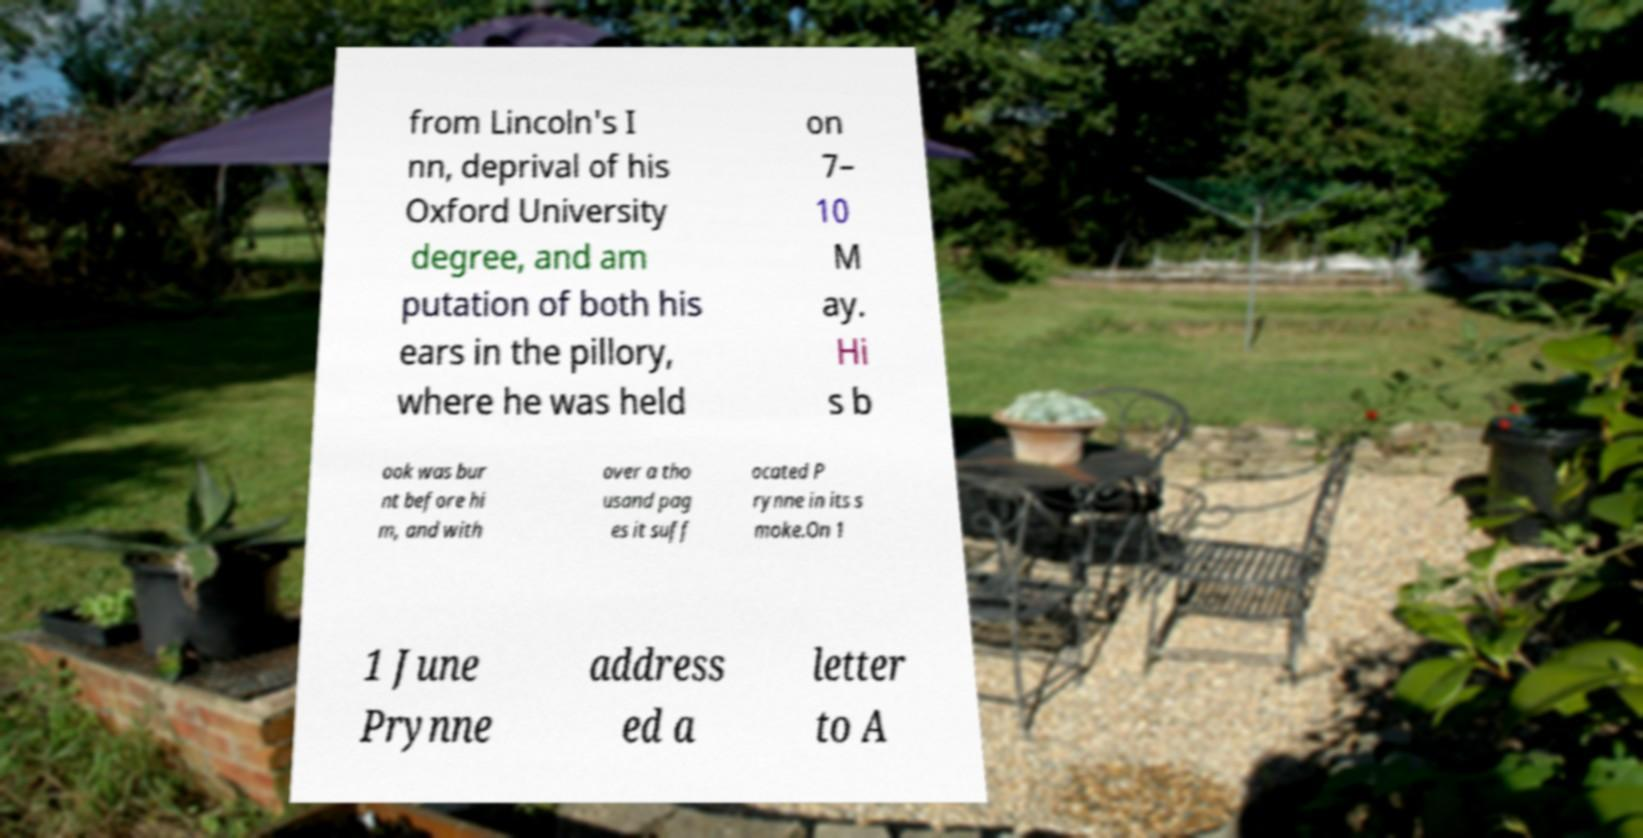There's text embedded in this image that I need extracted. Can you transcribe it verbatim? from Lincoln's I nn, deprival of his Oxford University degree, and am putation of both his ears in the pillory, where he was held on 7– 10 M ay. Hi s b ook was bur nt before hi m, and with over a tho usand pag es it suff ocated P rynne in its s moke.On 1 1 June Prynne address ed a letter to A 